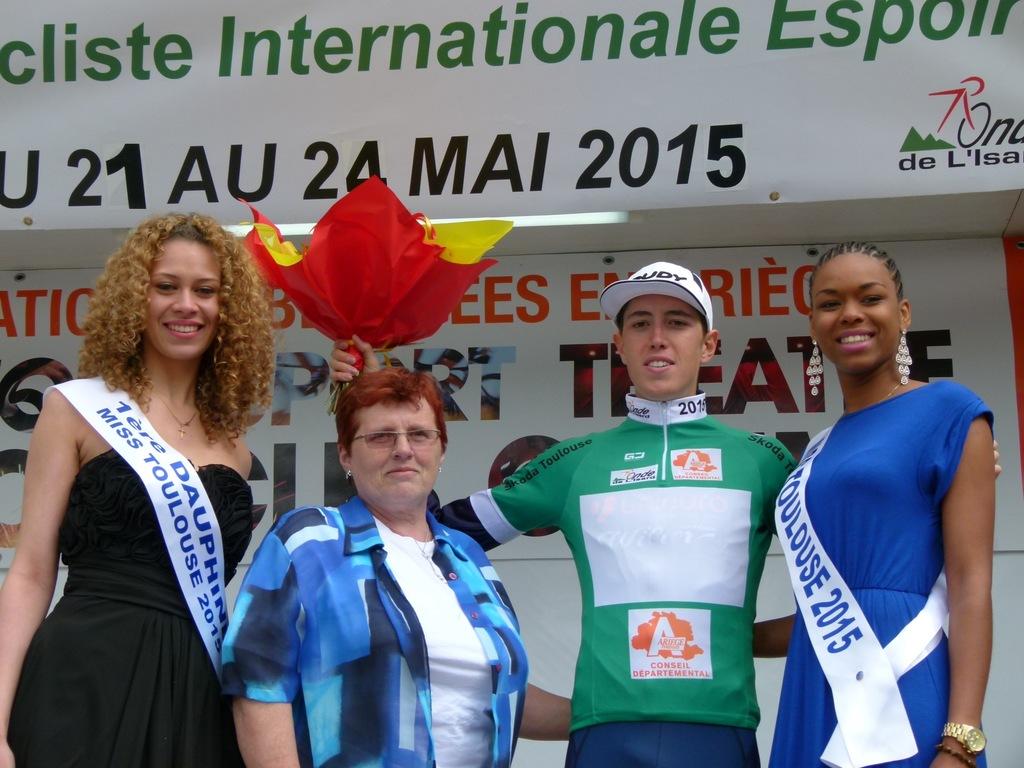What year is this event taking place?
Ensure brevity in your answer.  2015. 